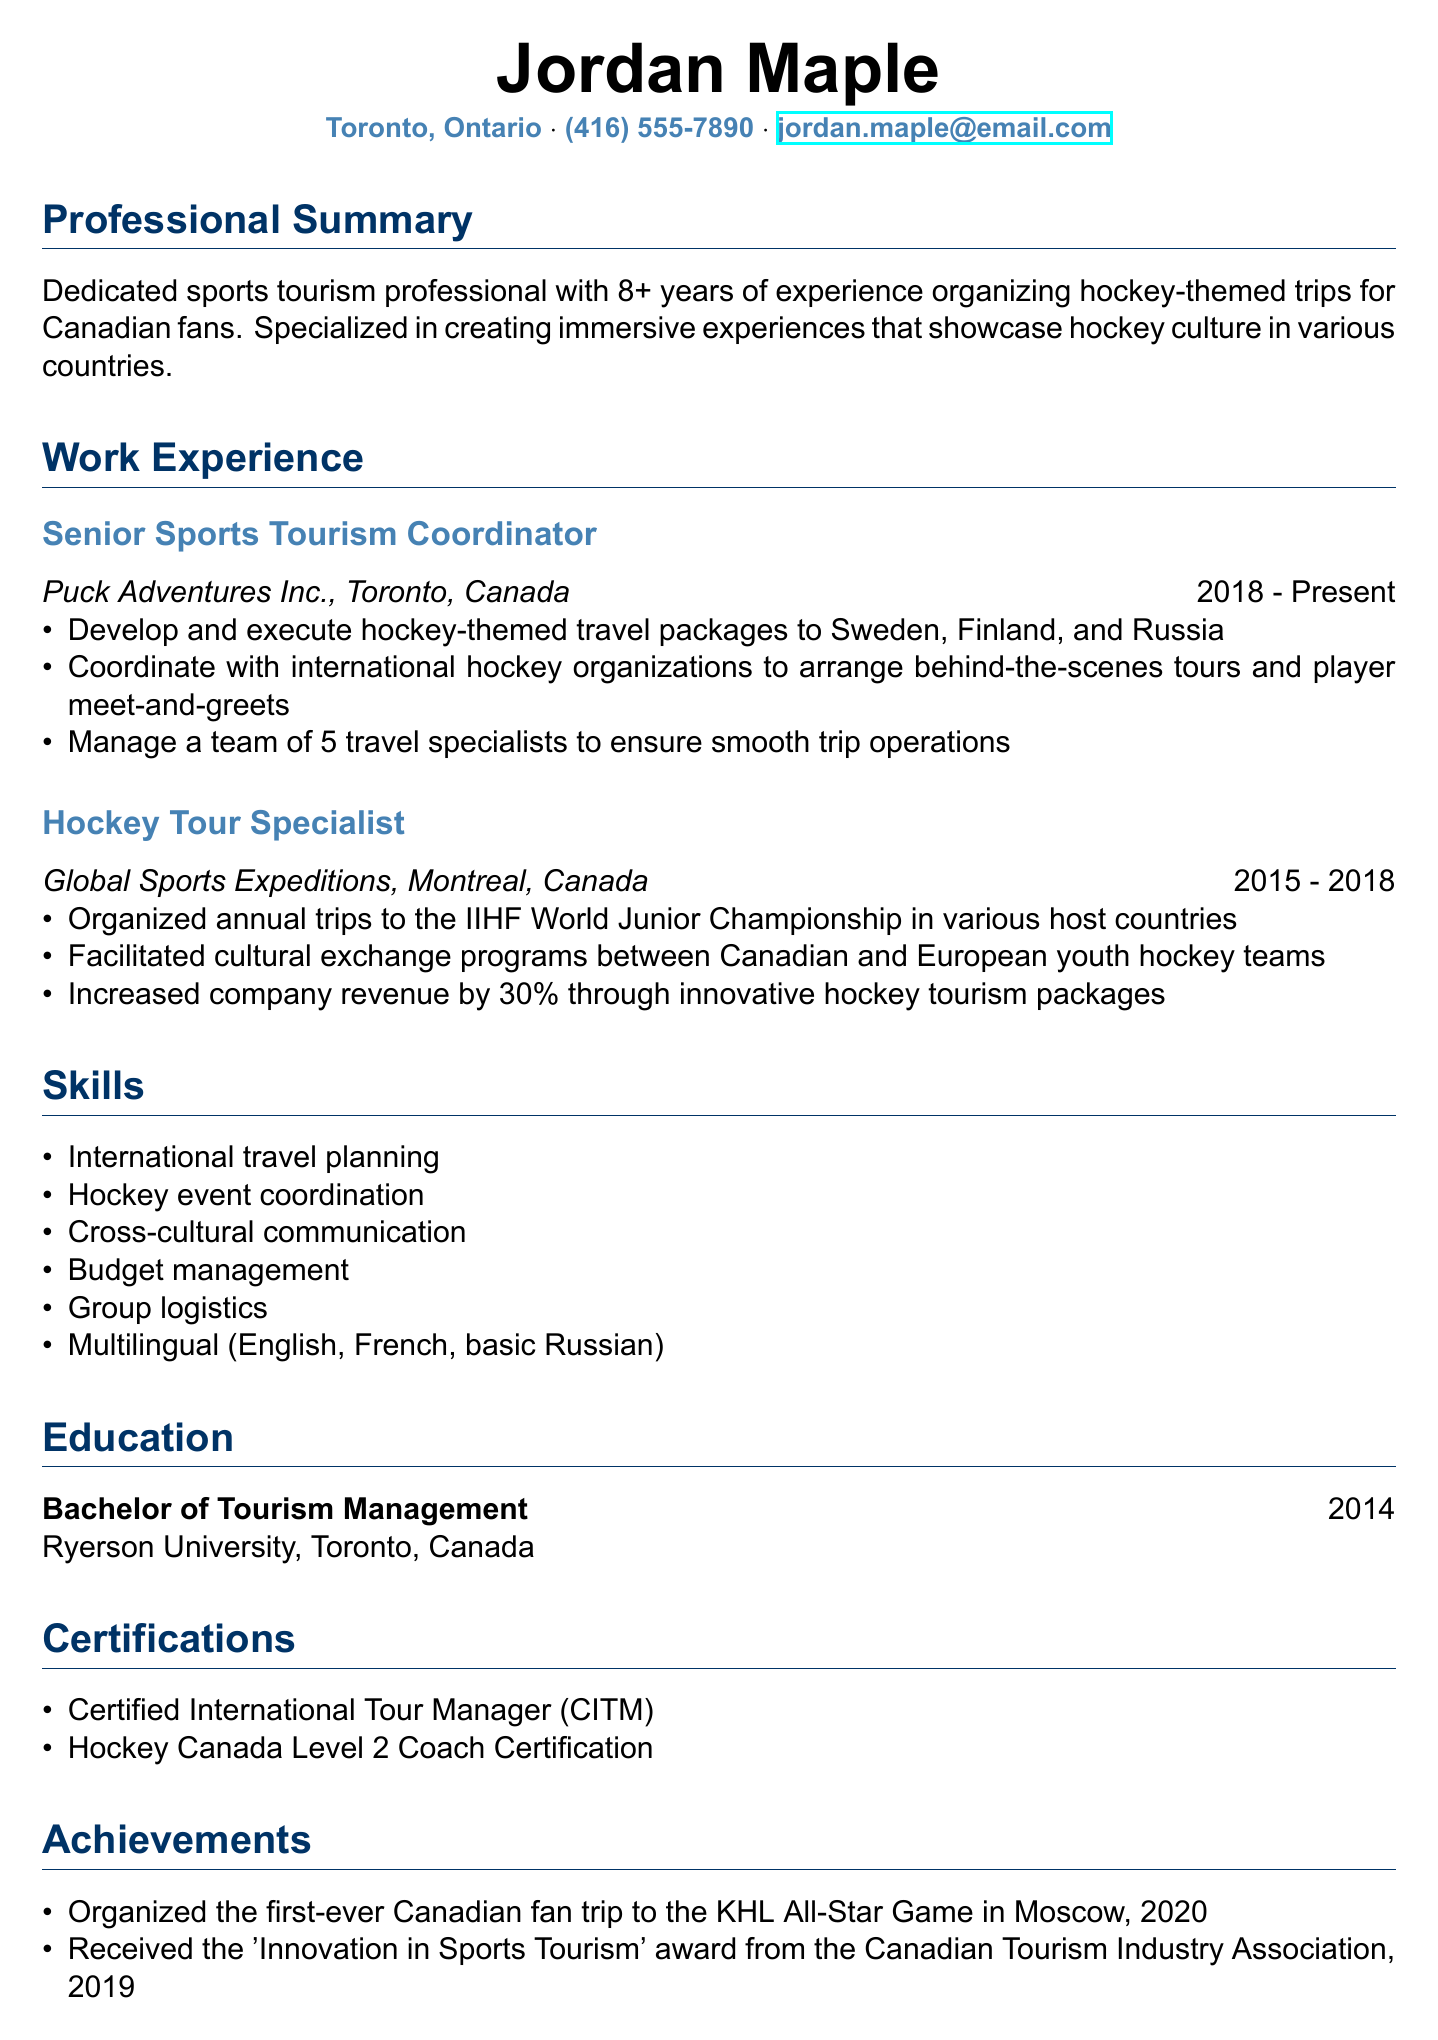What is the name of the individual? The document states the individual's name in the header.
Answer: Jordan Maple What city is the individual located in? The location is provided directly after the name in the contact information section.
Answer: Toronto, Ontario How many years of experience does the individual have? The summary section mentions the number of years of experience.
Answer: 8+ What position does the individual currently hold? The current position is listed in the work experience section.
Answer: Senior Sports Tourism Coordinator What company did the individual work for before Puck Adventures Inc.? The previous employer before the current position is mentioned in the work experience section.
Answer: Global Sports Expeditions In which year did the individual graduate? The education section lists the graduation year directly.
Answer: 2014 What award did the individual receive in 2019? The achievements section outlines the award received in that year.
Answer: Innovation in Sports Tourism How many team members does the individual manage? The responsibilities of the current position indicate team management.
Answer: 5 What language skills does the individual have? The skills section lists multilingual abilities.
Answer: English, French, basic Russian What type of certification does the individual hold related to coaching? The certifications section specifies the type of coaching certification held.
Answer: Hockey Canada Level 2 Coach Certification 